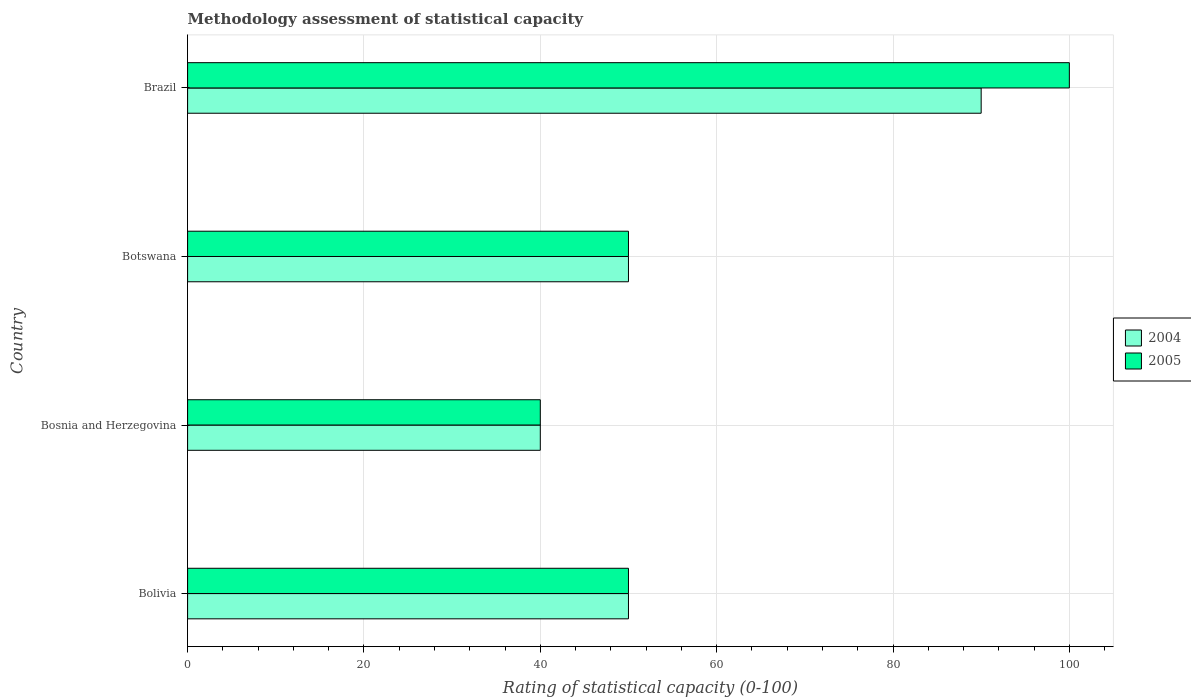How many groups of bars are there?
Offer a terse response. 4. Are the number of bars on each tick of the Y-axis equal?
Your response must be concise. Yes. How many bars are there on the 1st tick from the top?
Keep it short and to the point. 2. How many bars are there on the 2nd tick from the bottom?
Ensure brevity in your answer.  2. What is the label of the 1st group of bars from the top?
Give a very brief answer. Brazil. In which country was the rating of statistical capacity in 2005 maximum?
Provide a succinct answer. Brazil. In which country was the rating of statistical capacity in 2004 minimum?
Keep it short and to the point. Bosnia and Herzegovina. What is the total rating of statistical capacity in 2004 in the graph?
Your response must be concise. 230. What is the difference between the rating of statistical capacity in 2004 in Bosnia and Herzegovina and that in Botswana?
Offer a terse response. -10. What is the average rating of statistical capacity in 2004 per country?
Make the answer very short. 57.5. What is the ratio of the rating of statistical capacity in 2004 in Bosnia and Herzegovina to that in Botswana?
Keep it short and to the point. 0.8. Is the difference between the rating of statistical capacity in 2004 in Bolivia and Botswana greater than the difference between the rating of statistical capacity in 2005 in Bolivia and Botswana?
Offer a terse response. No. What is the difference between the highest and the second highest rating of statistical capacity in 2004?
Make the answer very short. 40. In how many countries, is the rating of statistical capacity in 2004 greater than the average rating of statistical capacity in 2004 taken over all countries?
Your answer should be very brief. 1. What does the 1st bar from the top in Bosnia and Herzegovina represents?
Provide a short and direct response. 2005. What does the 2nd bar from the bottom in Botswana represents?
Give a very brief answer. 2005. How many countries are there in the graph?
Give a very brief answer. 4. What is the difference between two consecutive major ticks on the X-axis?
Your answer should be very brief. 20. Are the values on the major ticks of X-axis written in scientific E-notation?
Provide a succinct answer. No. Does the graph contain any zero values?
Your response must be concise. No. Does the graph contain grids?
Your answer should be very brief. Yes. How are the legend labels stacked?
Your answer should be compact. Vertical. What is the title of the graph?
Make the answer very short. Methodology assessment of statistical capacity. Does "2013" appear as one of the legend labels in the graph?
Ensure brevity in your answer.  No. What is the label or title of the X-axis?
Provide a succinct answer. Rating of statistical capacity (0-100). What is the Rating of statistical capacity (0-100) of 2005 in Bolivia?
Your answer should be very brief. 50. What is the Rating of statistical capacity (0-100) in 2004 in Brazil?
Provide a short and direct response. 90. What is the total Rating of statistical capacity (0-100) of 2004 in the graph?
Offer a very short reply. 230. What is the total Rating of statistical capacity (0-100) of 2005 in the graph?
Ensure brevity in your answer.  240. What is the difference between the Rating of statistical capacity (0-100) of 2004 in Bolivia and that in Bosnia and Herzegovina?
Offer a very short reply. 10. What is the difference between the Rating of statistical capacity (0-100) in 2004 in Bolivia and that in Botswana?
Give a very brief answer. 0. What is the difference between the Rating of statistical capacity (0-100) in 2004 in Bolivia and that in Brazil?
Keep it short and to the point. -40. What is the difference between the Rating of statistical capacity (0-100) of 2005 in Bolivia and that in Brazil?
Provide a succinct answer. -50. What is the difference between the Rating of statistical capacity (0-100) of 2004 in Bosnia and Herzegovina and that in Brazil?
Your response must be concise. -50. What is the difference between the Rating of statistical capacity (0-100) of 2005 in Bosnia and Herzegovina and that in Brazil?
Give a very brief answer. -60. What is the difference between the Rating of statistical capacity (0-100) in 2004 in Botswana and that in Brazil?
Your answer should be very brief. -40. What is the difference between the Rating of statistical capacity (0-100) of 2005 in Botswana and that in Brazil?
Your answer should be very brief. -50. What is the difference between the Rating of statistical capacity (0-100) of 2004 in Bolivia and the Rating of statistical capacity (0-100) of 2005 in Bosnia and Herzegovina?
Provide a succinct answer. 10. What is the difference between the Rating of statistical capacity (0-100) of 2004 in Bolivia and the Rating of statistical capacity (0-100) of 2005 in Botswana?
Provide a succinct answer. 0. What is the difference between the Rating of statistical capacity (0-100) of 2004 in Bolivia and the Rating of statistical capacity (0-100) of 2005 in Brazil?
Provide a short and direct response. -50. What is the difference between the Rating of statistical capacity (0-100) of 2004 in Bosnia and Herzegovina and the Rating of statistical capacity (0-100) of 2005 in Brazil?
Your answer should be compact. -60. What is the average Rating of statistical capacity (0-100) of 2004 per country?
Give a very brief answer. 57.5. What is the average Rating of statistical capacity (0-100) of 2005 per country?
Your response must be concise. 60. What is the ratio of the Rating of statistical capacity (0-100) in 2004 in Bolivia to that in Bosnia and Herzegovina?
Your response must be concise. 1.25. What is the ratio of the Rating of statistical capacity (0-100) in 2005 in Bolivia to that in Bosnia and Herzegovina?
Make the answer very short. 1.25. What is the ratio of the Rating of statistical capacity (0-100) of 2004 in Bolivia to that in Botswana?
Your answer should be very brief. 1. What is the ratio of the Rating of statistical capacity (0-100) of 2005 in Bolivia to that in Botswana?
Offer a very short reply. 1. What is the ratio of the Rating of statistical capacity (0-100) of 2004 in Bolivia to that in Brazil?
Provide a short and direct response. 0.56. What is the ratio of the Rating of statistical capacity (0-100) in 2004 in Bosnia and Herzegovina to that in Botswana?
Your answer should be very brief. 0.8. What is the ratio of the Rating of statistical capacity (0-100) in 2005 in Bosnia and Herzegovina to that in Botswana?
Your answer should be compact. 0.8. What is the ratio of the Rating of statistical capacity (0-100) of 2004 in Bosnia and Herzegovina to that in Brazil?
Your answer should be compact. 0.44. What is the ratio of the Rating of statistical capacity (0-100) of 2005 in Bosnia and Herzegovina to that in Brazil?
Offer a very short reply. 0.4. What is the ratio of the Rating of statistical capacity (0-100) in 2004 in Botswana to that in Brazil?
Provide a succinct answer. 0.56. What is the ratio of the Rating of statistical capacity (0-100) in 2005 in Botswana to that in Brazil?
Your response must be concise. 0.5. What is the difference between the highest and the second highest Rating of statistical capacity (0-100) of 2004?
Your response must be concise. 40. 